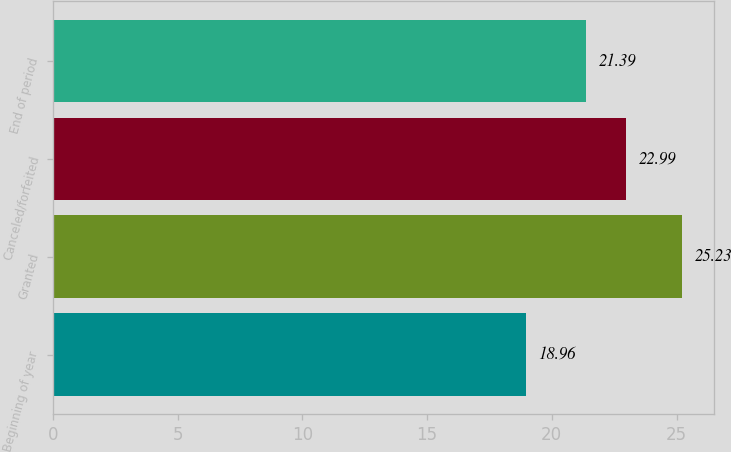Convert chart. <chart><loc_0><loc_0><loc_500><loc_500><bar_chart><fcel>Beginning of year<fcel>Granted<fcel>Canceled/forfeited<fcel>End of period<nl><fcel>18.96<fcel>25.23<fcel>22.99<fcel>21.39<nl></chart> 